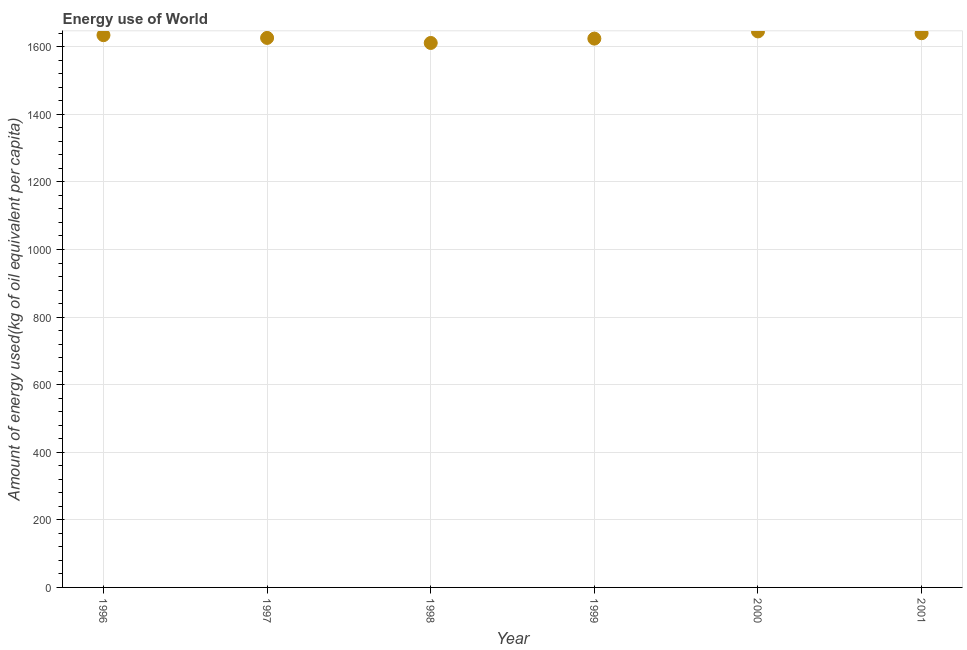What is the amount of energy used in 2000?
Your response must be concise. 1645.43. Across all years, what is the maximum amount of energy used?
Ensure brevity in your answer.  1645.43. Across all years, what is the minimum amount of energy used?
Your answer should be very brief. 1611.23. In which year was the amount of energy used maximum?
Ensure brevity in your answer.  2000. In which year was the amount of energy used minimum?
Offer a very short reply. 1998. What is the sum of the amount of energy used?
Your answer should be very brief. 9781.36. What is the difference between the amount of energy used in 1999 and 2001?
Make the answer very short. -15.96. What is the average amount of energy used per year?
Offer a very short reply. 1630.23. What is the median amount of energy used?
Keep it short and to the point. 1630.26. In how many years, is the amount of energy used greater than 1040 kg?
Your answer should be compact. 6. What is the ratio of the amount of energy used in 1998 to that in 2001?
Keep it short and to the point. 0.98. Is the amount of energy used in 1996 less than that in 2001?
Offer a very short reply. Yes. What is the difference between the highest and the second highest amount of energy used?
Ensure brevity in your answer.  5.37. What is the difference between the highest and the lowest amount of energy used?
Your response must be concise. 34.21. Does the amount of energy used monotonically increase over the years?
Provide a succinct answer. No. How many dotlines are there?
Give a very brief answer. 1. What is the difference between two consecutive major ticks on the Y-axis?
Provide a short and direct response. 200. Does the graph contain any zero values?
Your answer should be very brief. No. What is the title of the graph?
Your answer should be very brief. Energy use of World. What is the label or title of the Y-axis?
Offer a terse response. Amount of energy used(kg of oil equivalent per capita). What is the Amount of energy used(kg of oil equivalent per capita) in 1996?
Your answer should be very brief. 1634.34. What is the Amount of energy used(kg of oil equivalent per capita) in 1997?
Give a very brief answer. 1626.18. What is the Amount of energy used(kg of oil equivalent per capita) in 1998?
Provide a short and direct response. 1611.23. What is the Amount of energy used(kg of oil equivalent per capita) in 1999?
Make the answer very short. 1624.11. What is the Amount of energy used(kg of oil equivalent per capita) in 2000?
Keep it short and to the point. 1645.43. What is the Amount of energy used(kg of oil equivalent per capita) in 2001?
Your response must be concise. 1640.07. What is the difference between the Amount of energy used(kg of oil equivalent per capita) in 1996 and 1997?
Make the answer very short. 8.16. What is the difference between the Amount of energy used(kg of oil equivalent per capita) in 1996 and 1998?
Make the answer very short. 23.11. What is the difference between the Amount of energy used(kg of oil equivalent per capita) in 1996 and 1999?
Give a very brief answer. 10.23. What is the difference between the Amount of energy used(kg of oil equivalent per capita) in 1996 and 2000?
Provide a short and direct response. -11.1. What is the difference between the Amount of energy used(kg of oil equivalent per capita) in 1996 and 2001?
Provide a succinct answer. -5.73. What is the difference between the Amount of energy used(kg of oil equivalent per capita) in 1997 and 1998?
Make the answer very short. 14.95. What is the difference between the Amount of energy used(kg of oil equivalent per capita) in 1997 and 1999?
Offer a very short reply. 2.07. What is the difference between the Amount of energy used(kg of oil equivalent per capita) in 1997 and 2000?
Provide a succinct answer. -19.25. What is the difference between the Amount of energy used(kg of oil equivalent per capita) in 1997 and 2001?
Give a very brief answer. -13.89. What is the difference between the Amount of energy used(kg of oil equivalent per capita) in 1998 and 1999?
Your response must be concise. -12.88. What is the difference between the Amount of energy used(kg of oil equivalent per capita) in 1998 and 2000?
Your answer should be compact. -34.21. What is the difference between the Amount of energy used(kg of oil equivalent per capita) in 1998 and 2001?
Offer a terse response. -28.84. What is the difference between the Amount of energy used(kg of oil equivalent per capita) in 1999 and 2000?
Your response must be concise. -21.32. What is the difference between the Amount of energy used(kg of oil equivalent per capita) in 1999 and 2001?
Your answer should be compact. -15.96. What is the difference between the Amount of energy used(kg of oil equivalent per capita) in 2000 and 2001?
Provide a short and direct response. 5.37. What is the ratio of the Amount of energy used(kg of oil equivalent per capita) in 1996 to that in 1997?
Give a very brief answer. 1. What is the ratio of the Amount of energy used(kg of oil equivalent per capita) in 1996 to that in 2001?
Your answer should be compact. 1. What is the ratio of the Amount of energy used(kg of oil equivalent per capita) in 1997 to that in 1998?
Make the answer very short. 1.01. What is the ratio of the Amount of energy used(kg of oil equivalent per capita) in 1997 to that in 1999?
Offer a terse response. 1. What is the ratio of the Amount of energy used(kg of oil equivalent per capita) in 1997 to that in 2001?
Make the answer very short. 0.99. What is the ratio of the Amount of energy used(kg of oil equivalent per capita) in 1998 to that in 1999?
Make the answer very short. 0.99. What is the ratio of the Amount of energy used(kg of oil equivalent per capita) in 1998 to that in 2001?
Provide a succinct answer. 0.98. What is the ratio of the Amount of energy used(kg of oil equivalent per capita) in 1999 to that in 2001?
Provide a short and direct response. 0.99. 